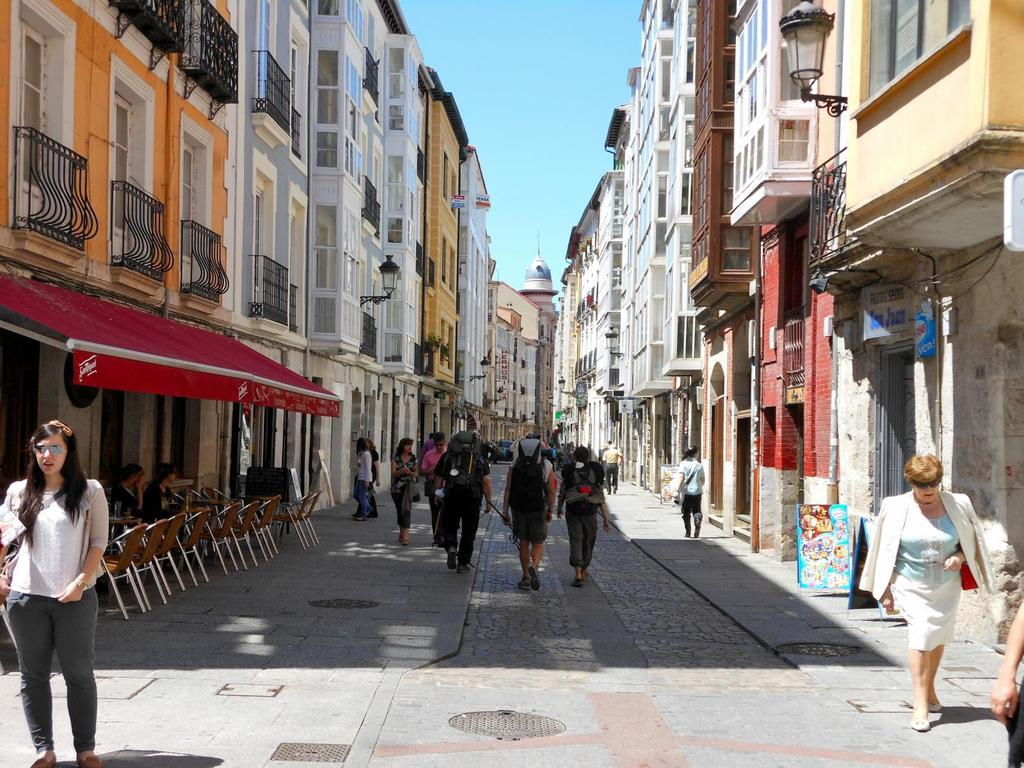Who or what can be seen in the image? There are people in the image. What type of structures are visible in the image? There are buildings in the image. Where are the chairs located in the image? The chairs are on the left side of the image. What does the pig taste like in the image? There is no pig present in the image, so it is not possible to determine its taste. 